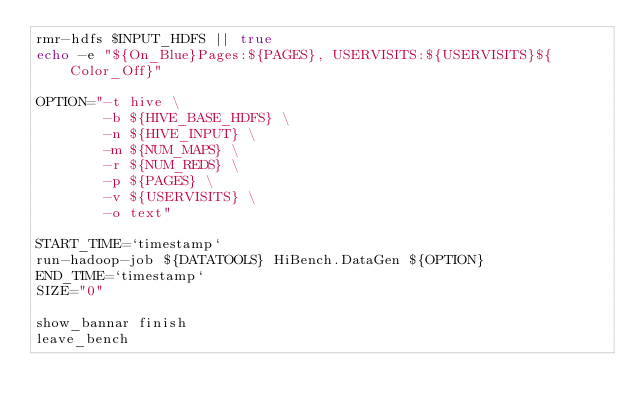Convert code to text. <code><loc_0><loc_0><loc_500><loc_500><_Bash_>rmr-hdfs $INPUT_HDFS || true
echo -e "${On_Blue}Pages:${PAGES}, USERVISITS:${USERVISITS}${Color_Off}"

OPTION="-t hive \
        -b ${HIVE_BASE_HDFS} \
        -n ${HIVE_INPUT} \
        -m ${NUM_MAPS} \
        -r ${NUM_REDS} \
        -p ${PAGES} \
        -v ${USERVISITS} \
        -o text"

START_TIME=`timestamp`
run-hadoop-job ${DATATOOLS} HiBench.DataGen ${OPTION}  
END_TIME=`timestamp`
SIZE="0"

show_bannar finish
leave_bench


</code> 